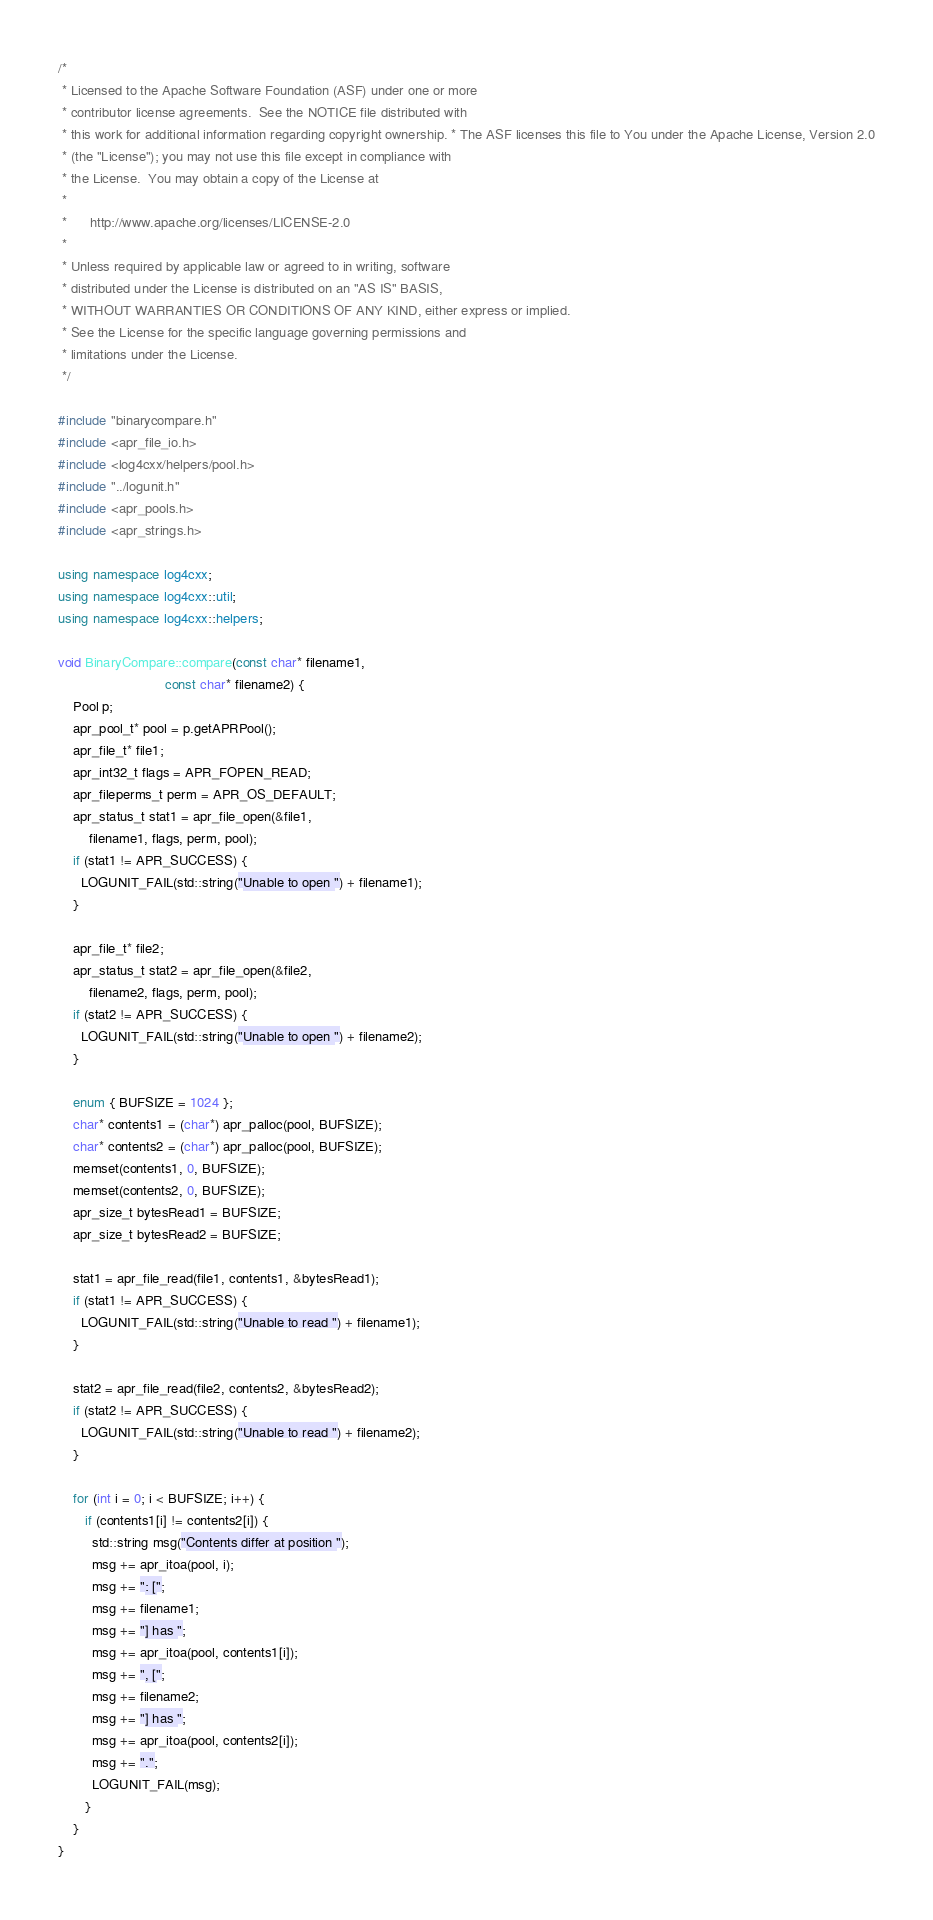Convert code to text. <code><loc_0><loc_0><loc_500><loc_500><_C++_>/*
 * Licensed to the Apache Software Foundation (ASF) under one or more
 * contributor license agreements.  See the NOTICE file distributed with
 * this work for additional information regarding copyright ownership. * The ASF licenses this file to You under the Apache License, Version 2.0
 * (the "License"); you may not use this file except in compliance with
 * the License.  You may obtain a copy of the License at
 *
 *      http://www.apache.org/licenses/LICENSE-2.0
 *
 * Unless required by applicable law or agreed to in writing, software
 * distributed under the License is distributed on an "AS IS" BASIS,
 * WITHOUT WARRANTIES OR CONDITIONS OF ANY KIND, either express or implied.
 * See the License for the specific language governing permissions and
 * limitations under the License.
 */

#include "binarycompare.h"
#include <apr_file_io.h>
#include <log4cxx/helpers/pool.h>
#include "../logunit.h"
#include <apr_pools.h>
#include <apr_strings.h>

using namespace log4cxx;
using namespace log4cxx::util;
using namespace log4cxx::helpers;

void BinaryCompare::compare(const char* filename1,
                            const char* filename2) {
    Pool p;
    apr_pool_t* pool = p.getAPRPool();
    apr_file_t* file1;
    apr_int32_t flags = APR_FOPEN_READ;
    apr_fileperms_t perm = APR_OS_DEFAULT;
    apr_status_t stat1 = apr_file_open(&file1,
        filename1, flags, perm, pool);
    if (stat1 != APR_SUCCESS) {
      LOGUNIT_FAIL(std::string("Unable to open ") + filename1);
    }

    apr_file_t* file2;
    apr_status_t stat2 = apr_file_open(&file2,
        filename2, flags, perm, pool);
    if (stat2 != APR_SUCCESS) {
      LOGUNIT_FAIL(std::string("Unable to open ") + filename2);
    }

    enum { BUFSIZE = 1024 };
    char* contents1 = (char*) apr_palloc(pool, BUFSIZE);
    char* contents2 = (char*) apr_palloc(pool, BUFSIZE);
    memset(contents1, 0, BUFSIZE);
    memset(contents2, 0, BUFSIZE);
    apr_size_t bytesRead1 = BUFSIZE;
    apr_size_t bytesRead2 = BUFSIZE;

    stat1 = apr_file_read(file1, contents1, &bytesRead1);
    if (stat1 != APR_SUCCESS) {
      LOGUNIT_FAIL(std::string("Unable to read ") + filename1);
    }

    stat2 = apr_file_read(file2, contents2, &bytesRead2);
    if (stat2 != APR_SUCCESS) {
      LOGUNIT_FAIL(std::string("Unable to read ") + filename2);
    }

    for (int i = 0; i < BUFSIZE; i++) {
       if (contents1[i] != contents2[i]) {
         std::string msg("Contents differ at position ");
         msg += apr_itoa(pool, i);
         msg += ": [";
         msg += filename1;
         msg += "] has ";
         msg += apr_itoa(pool, contents1[i]);
         msg += ", [";
         msg += filename2;
         msg += "] has ";
         msg += apr_itoa(pool, contents2[i]);
         msg += ".";
         LOGUNIT_FAIL(msg);
       }
    }
}
</code> 